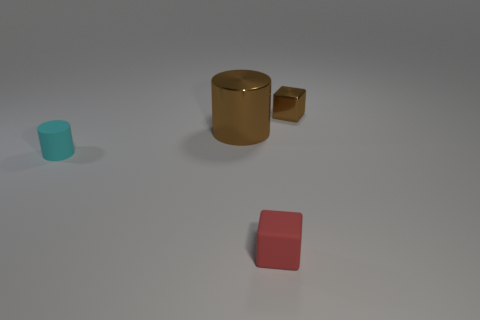Add 2 green matte cylinders. How many objects exist? 6 Subtract 1 cylinders. How many cylinders are left? 1 Subtract 0 green cubes. How many objects are left? 4 Subtract all cyan blocks. Subtract all red cylinders. How many blocks are left? 2 Subtract all blue spheres. How many red blocks are left? 1 Subtract all small gray metal blocks. Subtract all rubber things. How many objects are left? 2 Add 4 matte cylinders. How many matte cylinders are left? 5 Add 4 big gray cylinders. How many big gray cylinders exist? 4 